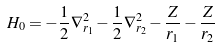Convert formula to latex. <formula><loc_0><loc_0><loc_500><loc_500>H _ { 0 } = - { \frac { 1 } { 2 } } \nabla _ { r _ { 1 } } ^ { 2 } - { \frac { 1 } { 2 } } \nabla _ { r _ { 2 } } ^ { 2 } - { \frac { Z } { r _ { 1 } } } - { \frac { Z } { r _ { 2 } } }</formula> 